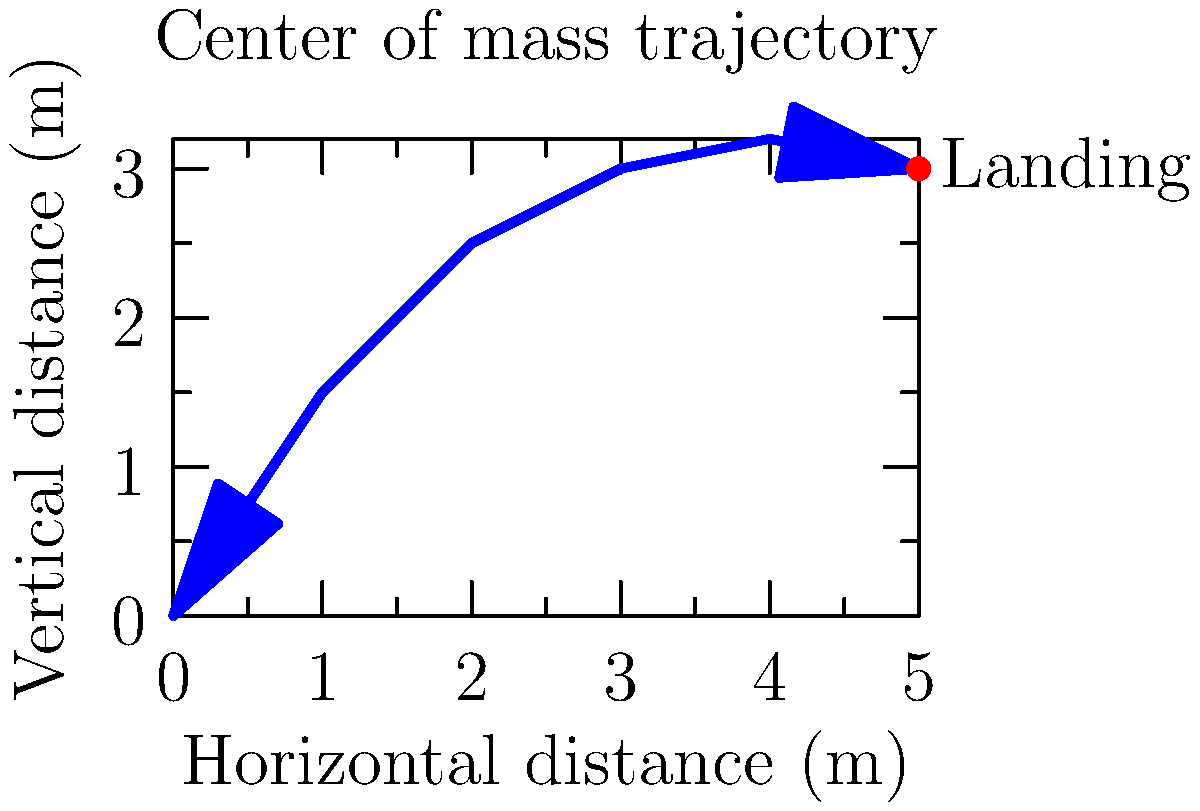During a long jump, an athlete's center of mass follows the trajectory shown in the graph. At which point in the jump does the athlete experience the greatest vertical velocity? To determine when the athlete experiences the greatest vertical velocity during the long jump, we need to analyze the trajectory of the center of mass:

1. The vertical velocity is represented by the slope of the curve at any given point.
2. A steeper positive slope indicates a higher upward vertical velocity.
3. The slope is steepest at the beginning of the jump, between 0 and 1 meter horizontally.
4. As the jump progresses, the slope gradually decreases, indicating a decrease in vertical velocity.
5. The highest point of the trajectory (peak) occurs around 4 meters horizontally, where the vertical velocity momentarily becomes zero.
6. After the peak, the slope becomes negative, indicating a downward vertical velocity.

Therefore, the greatest vertical velocity occurs at the very beginning of the jump, just after takeoff, when the curve is steepest.
Answer: At the beginning of the jump, just after takeoff. 